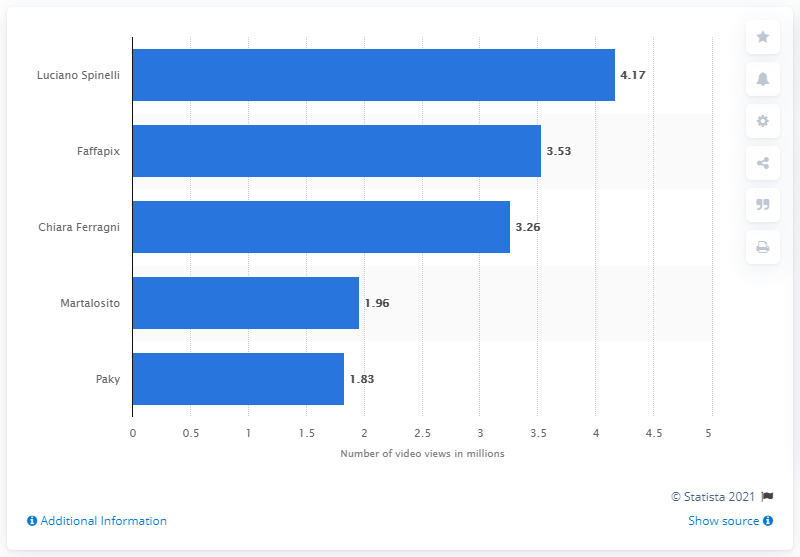Point out several critical features in this image. Luciano Spinelli was the most followed creator on Tik Tok in Italy. The number of individuals who viewed the short videos of Faffapix is 3.53... The total number of views for every video posted by the user Luciano Spinelli on Tik Tok between January and May 2020 was 4.17... 